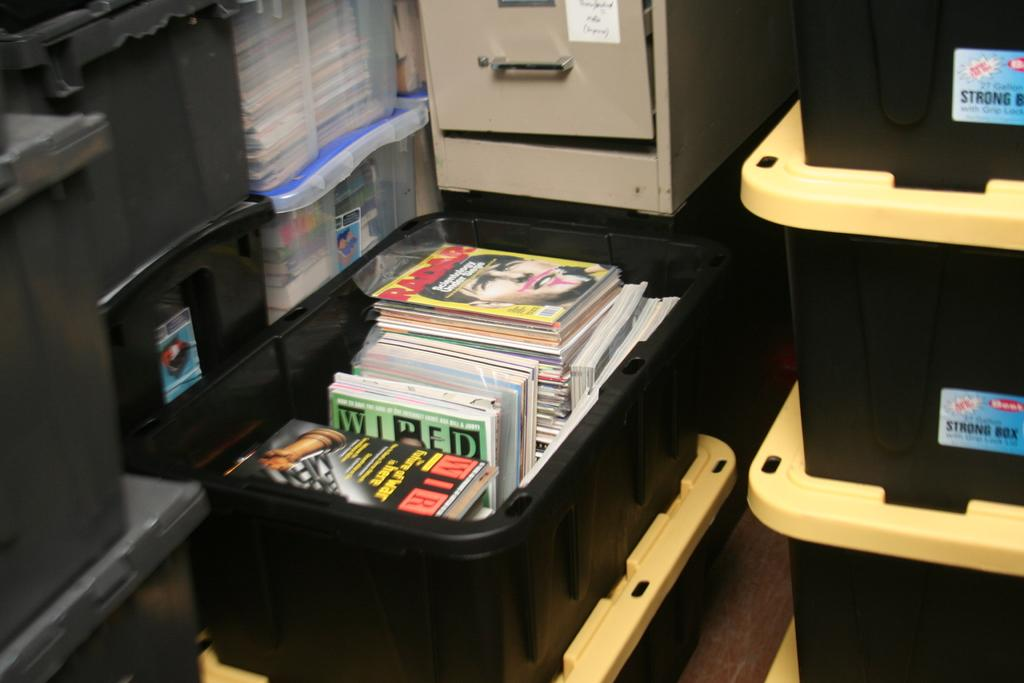<image>
Summarize the visual content of the image. a box of magazines including Wired and Radar 